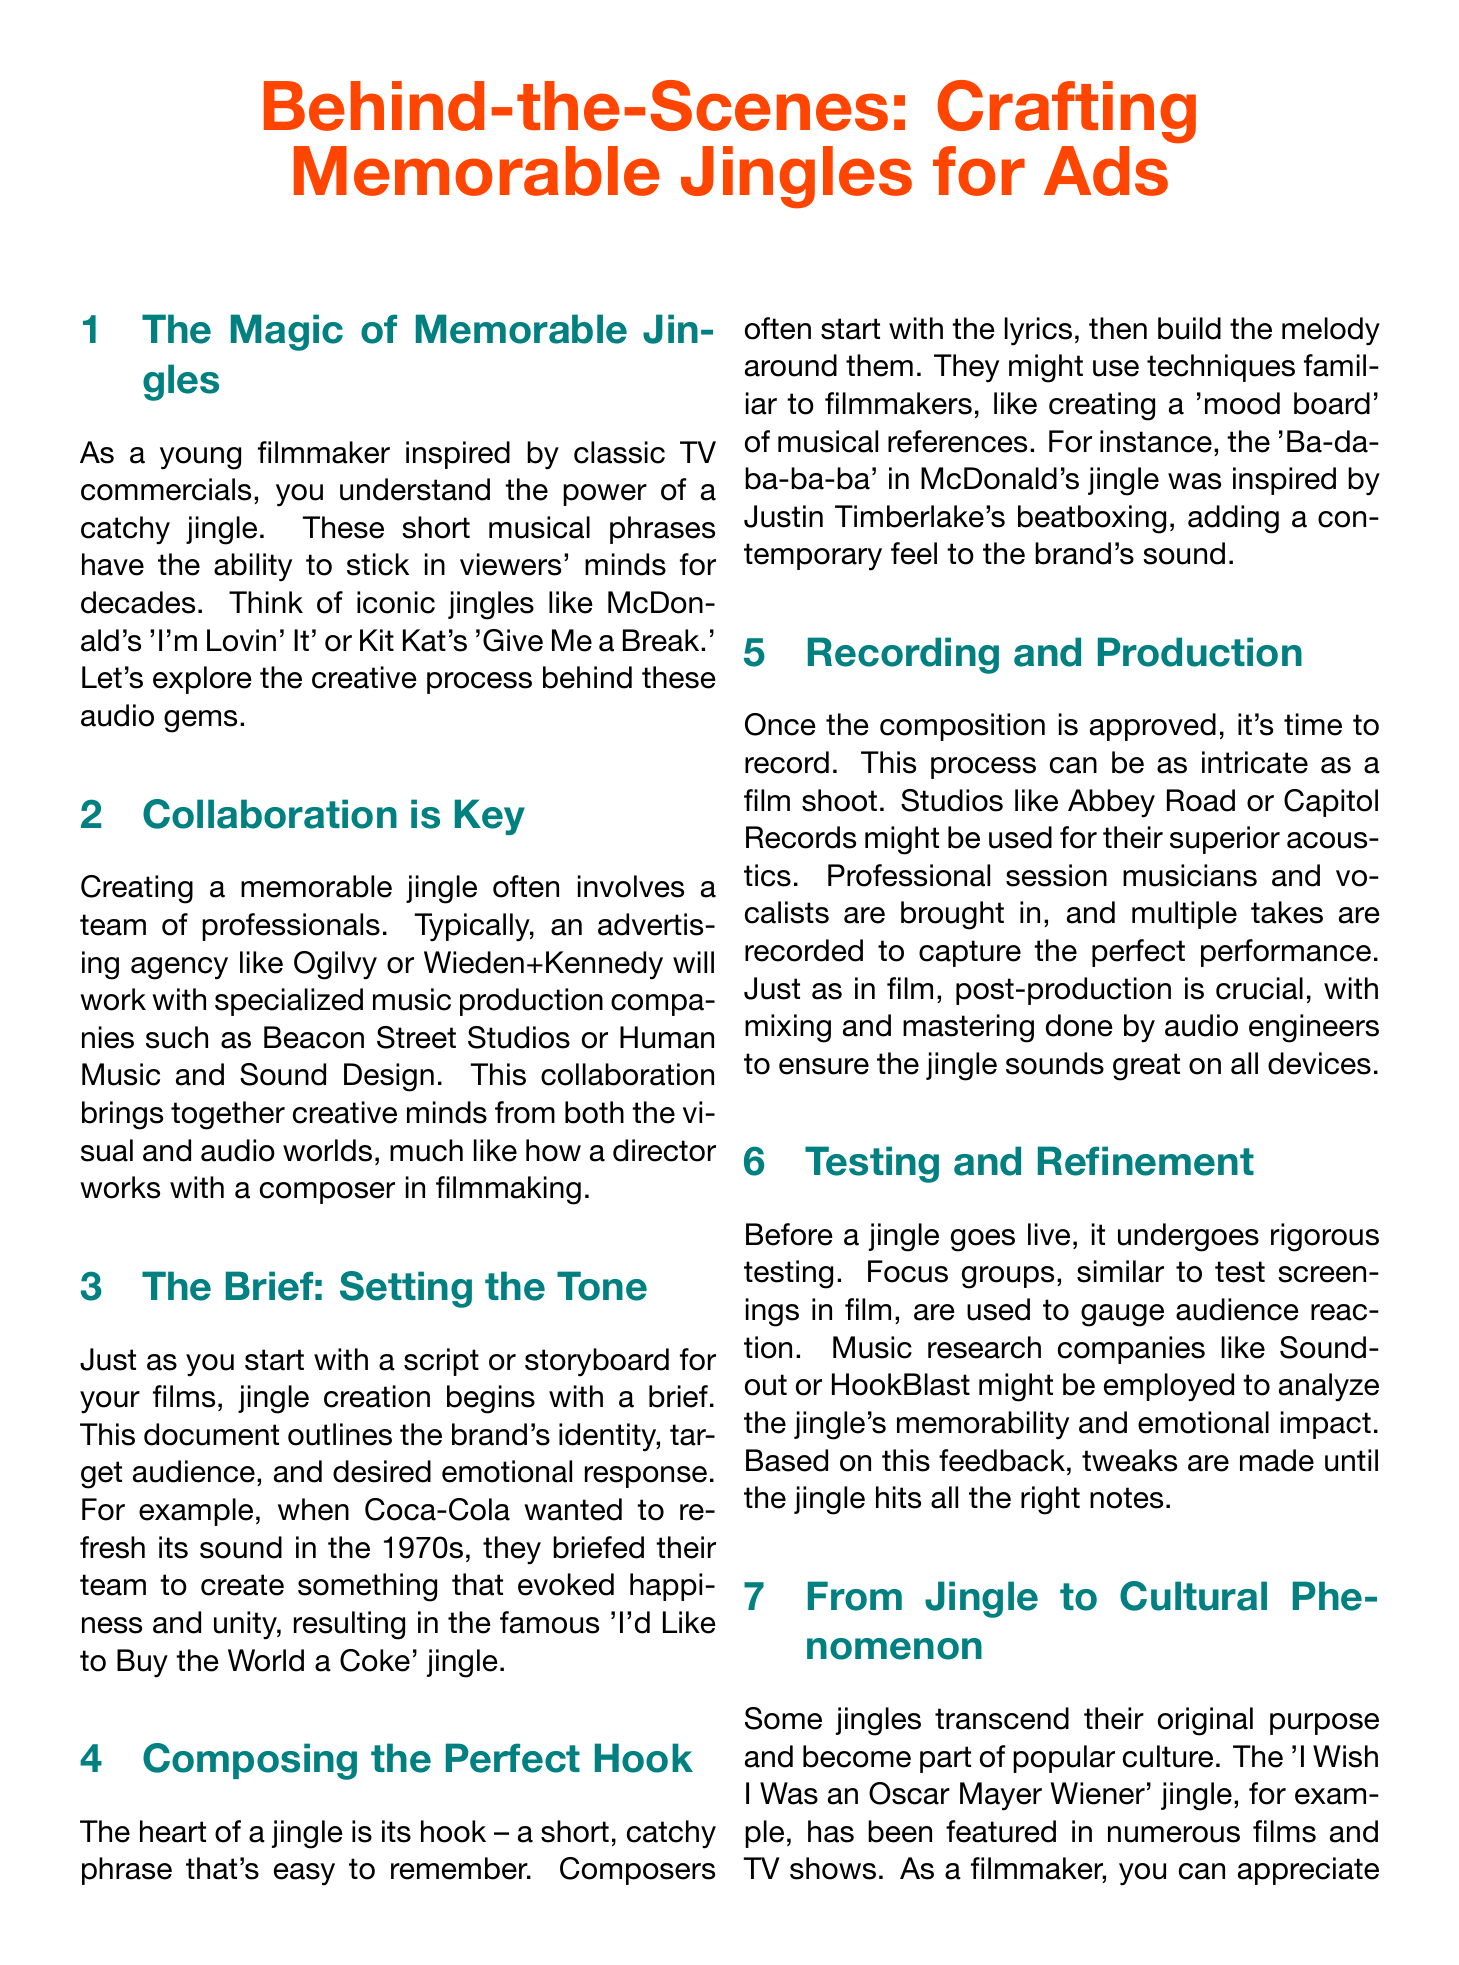What is the title of the newsletter? The title of the newsletter is stated at the beginning of the document.
Answer: Behind-the-Scenes: Crafting Memorable Jingles for Ads Who created the famous 'I'd Like to Buy the World a Coke' jingle? The brief for this jingle was focused on happiness and unity, which is directly mentioned in the document.
Answer: Coca-Cola What production studios are mentioned for recording jingles? The document provides examples of famous studios used for recording, highlighting their acoustics.
Answer: Abbey Road, Capitol Records What is the heart of a jingle referred to in the document? The document describes a central component of a jingle in specific terms.
Answer: Hook Which company is known for using popular songs in their ads? The document discusses a brand that has adopted this strategy, indicating its relevance in advertising.
Answer: Apple What type of companies analyze the jingle's memorability? The document mentions firms that focus on music research to assess jingles.
Answer: Music research companies What is the main purpose of a brief in jingle creation? The content outlines the initial step in creating a jingle, emphasizing its importance in the process.
Answer: Setting the tone What emotion did Coca-Cola want to evoke with their jingle in the 1970s? The document explicitly mentions the emotion targeted in Coca-Cola's jingle creation.
Answer: Happiness How does testing a jingle compare to film? The document explains a method used in the testing phase that relates to filmmaking practice.
Answer: Similar to test screenings 